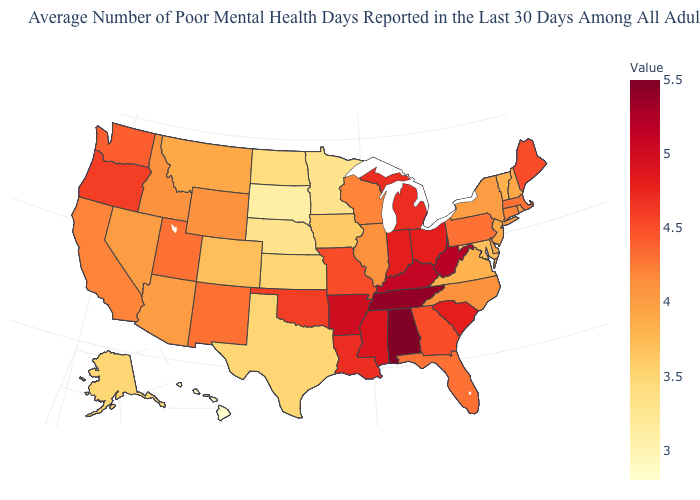Among the states that border Delaware , does Pennsylvania have the highest value?
Keep it brief. Yes. Among the states that border New York , which have the highest value?
Be succinct. Massachusetts, Pennsylvania. Which states have the lowest value in the USA?
Concise answer only. Hawaii. Among the states that border Colorado , which have the lowest value?
Concise answer only. Nebraska. Does New York have the lowest value in the Northeast?
Keep it brief. No. 